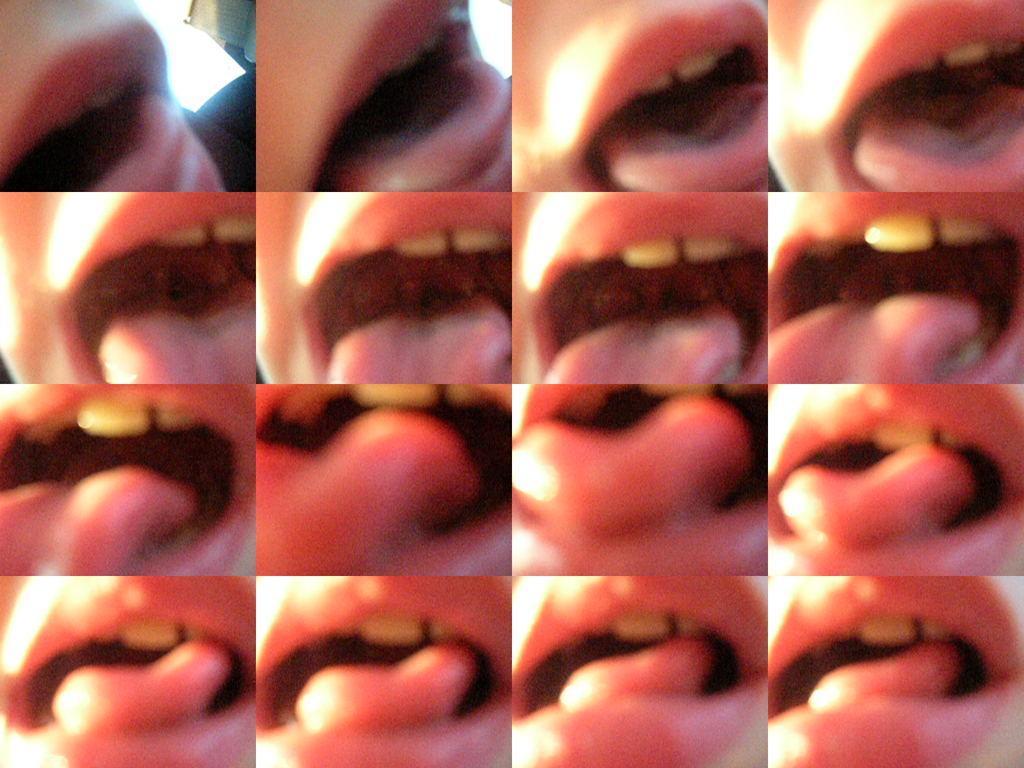Please provide a concise description of this image. This image contains collages of a person's mouth. 